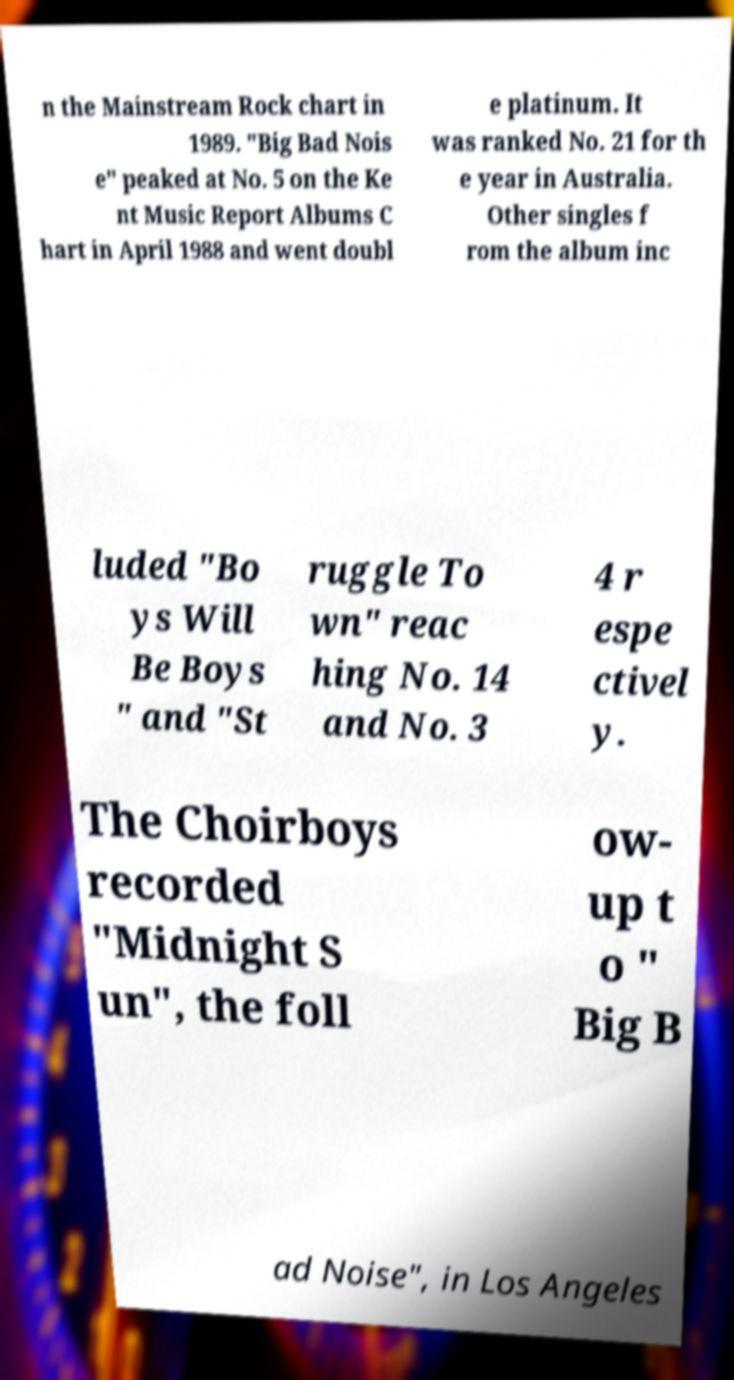I need the written content from this picture converted into text. Can you do that? n the Mainstream Rock chart in 1989. "Big Bad Nois e" peaked at No. 5 on the Ke nt Music Report Albums C hart in April 1988 and went doubl e platinum. It was ranked No. 21 for th e year in Australia. Other singles f rom the album inc luded "Bo ys Will Be Boys " and "St ruggle To wn" reac hing No. 14 and No. 3 4 r espe ctivel y. The Choirboys recorded "Midnight S un", the foll ow- up t o " Big B ad Noise", in Los Angeles 